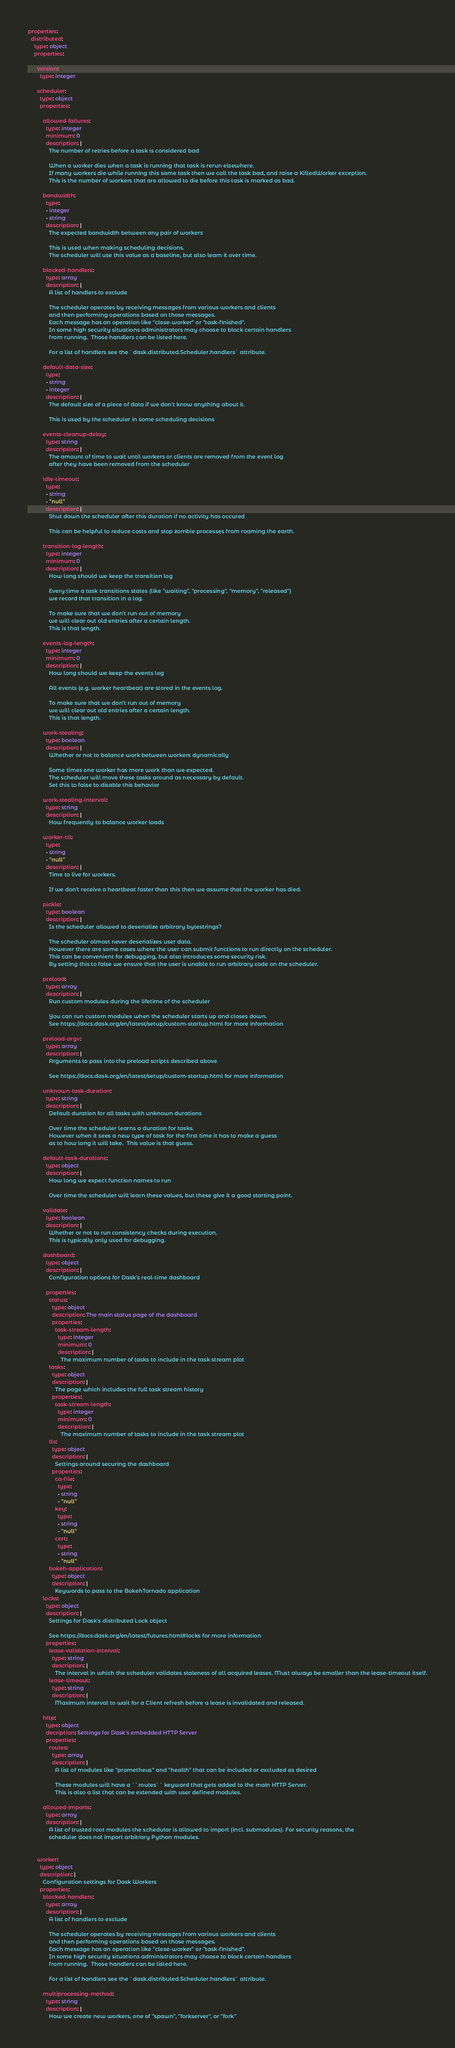Convert code to text. <code><loc_0><loc_0><loc_500><loc_500><_YAML_>properties:
  distributed:
    type: object
    properties:

      version:
        type: integer

      scheduler:
        type: object
        properties:

          allowed-failures:
            type: integer
            minimum: 0
            description: |
              The number of retries before a task is considered bad

              When a worker dies when a task is running that task is rerun elsewhere.
              If many workers die while running this same task then we call the task bad, and raise a KilledWorker exception.
              This is the number of workers that are allowed to die before this task is marked as bad.

          bandwidth:
            type:
            - integer
            - string
            description: |
              The expected bandwidth between any pair of workers

              This is used when making scheduling decisions.
              The scheduler will use this value as a baseline, but also learn it over time.

          blocked-handlers:
            type: array
            description: |
              A list of handlers to exclude

              The scheduler operates by receiving messages from various workers and clients
              and then performing operations based on those messages.
              Each message has an operation like "close-worker" or "task-finished".
              In some high security situations administrators may choose to block certain handlers
              from running.  Those handlers can be listed here.

              For a list of handlers see the `dask.distributed.Scheduler.handlers` attribute.

          default-data-size:
            type:
            - string
            - integer
            description: |
              The default size of a piece of data if we don't know anything about it.

              This is used by the scheduler in some scheduling decisions

          events-cleanup-delay:
            type: string
            description: |
              The amount of time to wait until workers or clients are removed from the event log
              after they have been removed from the scheduler

          idle-timeout:
            type:
            - string
            - "null"
            description: |
              Shut down the scheduler after this duration if no activity has occured

              This can be helpful to reduce costs and stop zombie processes from roaming the earth.

          transition-log-length:
            type: integer
            minimum: 0
            description: |
              How long should we keep the transition log

              Every time a task transitions states (like "waiting", "processing", "memory", "released")
              we record that transition in a log.

              To make sure that we don't run out of memory
              we will clear out old entries after a certain length.
              This is that length.

          events-log-length:
            type: integer
            minimum: 0
            description: |
              How long should we keep the events log

              All events (e.g. worker heartbeat) are stored in the events log.

              To make sure that we don't run out of memory
              we will clear out old entries after a certain length.
              This is that length.

          work-stealing:
            type: boolean
            description: |
              Whether or not to balance work between workers dynamically

              Some times one worker has more work than we expected.
              The scheduler will move these tasks around as necessary by default.
              Set this to false to disable this behavior

          work-stealing-interval:
            type: string
            description: |
              How frequently to balance worker loads

          worker-ttl:
            type:
            - string
            - "null"
            description: |
              Time to live for workers.

              If we don't receive a heartbeat faster than this then we assume that the worker has died.

          pickle:
            type: boolean
            description: |
              Is the scheduler allowed to deserialize arbitrary bytestrings?

              The scheduler almost never deserializes user data.
              However there are some cases where the user can submit functions to run directly on the scheduler.
              This can be convenient for debugging, but also introduces some security risk.
              By setting this to false we ensure that the user is unable to run arbitrary code on the scheduler.

          preload:
            type: array
            description: |
              Run custom modules during the lifetime of the scheduler

              You can run custom modules when the scheduler starts up and closes down.
              See https://docs.dask.org/en/latest/setup/custom-startup.html for more information

          preload-argv:
            type: array
            description: |
              Arguments to pass into the preload scripts described above

              See https://docs.dask.org/en/latest/setup/custom-startup.html for more information

          unknown-task-duration:
            type: string
            description: |
              Default duration for all tasks with unknown durations

              Over time the scheduler learns a duration for tasks.
              However when it sees a new type of task for the first time it has to make a guess
              as to how long it will take.  This value is that guess.

          default-task-durations:
            type: object
            description: |
              How long we expect function names to run

              Over time the scheduler will learn these values, but these give it a good starting point.

          validate:
            type: boolean
            description: |
              Whether or not to run consistency checks during execution.
              This is typically only used for debugging.

          dashboard:
            type: object
            description: |
              Configuration options for Dask's real-time dashboard

            properties:
              status:
                type: object
                description: The main status page of the dashboard
                properties:
                  task-stream-length:
                    type: integer
                    minimum: 0
                    description: |
                      The maximum number of tasks to include in the task stream plot
              tasks:
                type: object
                description: |
                  The page which includes the full task stream history
                properties:
                  task-stream-length:
                    type: integer
                    minimum: 0
                    description: |
                      The maximum number of tasks to include in the task stream plot
              tls:
                type: object
                description: |
                  Settings around securing the dashboard
                properties:
                  ca-file:
                    type:
                    - string
                    - "null"
                  key:
                    type:
                    - string
                    - "null"
                  cert:
                    type:
                    - string
                    - "null"
              bokeh-application:
                type: object
                description: |
                  Keywords to pass to the BokehTornado application
          locks:
            type: object
            description: |
              Settings for Dask's distributed Lock object

              See https://docs.dask.org/en/latest/futures.html#locks for more information
            properties:
              lease-validation-interval:
                type: string
                description: |
                  The interval in which the scheduler validates staleness of all acquired leases. Must always be smaller than the lease-timeout itself.
              lease-timeout:
                type: string
                description: |
                  Maximum interval to wait for a Client refresh before a lease is invalidated and released.

          http:
            type: object
            decription: Settings for Dask's embedded HTTP Server
            properties:
              routes:
                type: array
                description: |
                  A list of modules like "prometheus" and "health" that can be included or excluded as desired

                  These modules will have a ``routes`` keyword that gets added to the main HTTP Server.
                  This is also a list that can be extended with user defined modules.

          allowed-imports:
            type: array
            description: |
              A list of trusted root modules the schedular is allowed to import (incl. submodules). For security reasons, the
              scheduler does not import arbitrary Python modules.


      worker:
        type: object
        description: |
          Configuration settings for Dask Workers
        properties:
          blocked-handlers:
            type: array
            description: |
              A list of handlers to exclude

              The scheduler operates by receiving messages from various workers and clients
              and then performing operations based on those messages.
              Each message has an operation like "close-worker" or "task-finished".
              In some high security situations administrators may choose to block certain handlers
              from running.  Those handlers can be listed here.

              For a list of handlers see the `dask.distributed.Scheduler.handlers` attribute.

          multiprocessing-method:
            type: string
            description: |
              How we create new workers, one of "spawn", "forkserver", or "fork"
</code> 